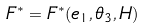<formula> <loc_0><loc_0><loc_500><loc_500>F ^ { * } = F ^ { * } ( e _ { 1 } , \theta _ { 3 } , H )</formula> 